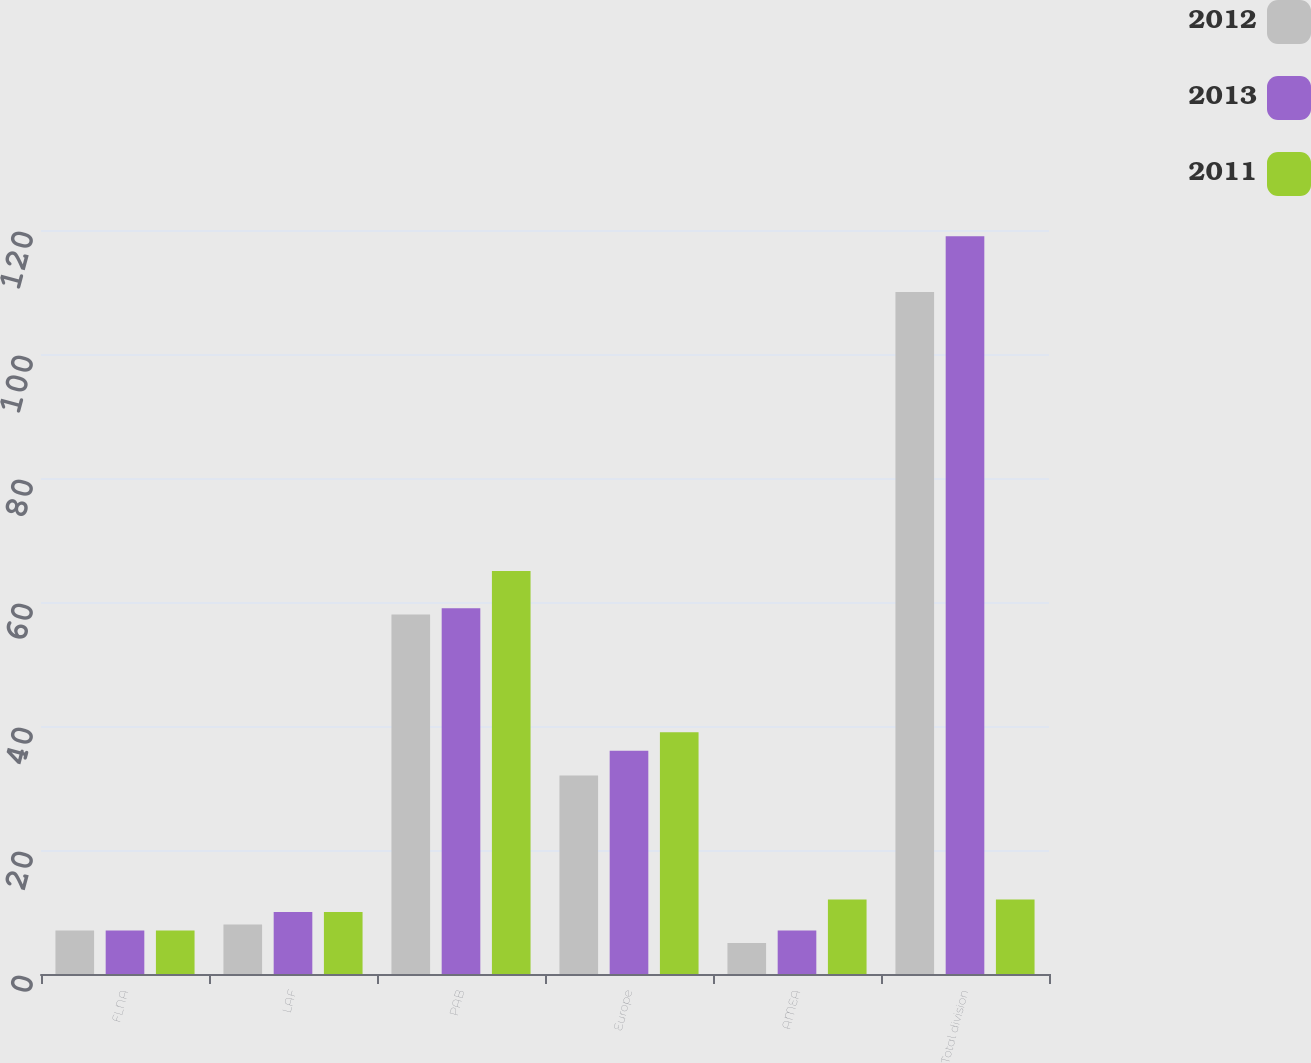<chart> <loc_0><loc_0><loc_500><loc_500><stacked_bar_chart><ecel><fcel>FLNA<fcel>LAF<fcel>PAB<fcel>Europe<fcel>AMEA<fcel>Total division<nl><fcel>2012<fcel>7<fcel>8<fcel>58<fcel>32<fcel>5<fcel>110<nl><fcel>2013<fcel>7<fcel>10<fcel>59<fcel>36<fcel>7<fcel>119<nl><fcel>2011<fcel>7<fcel>10<fcel>65<fcel>39<fcel>12<fcel>12<nl></chart> 